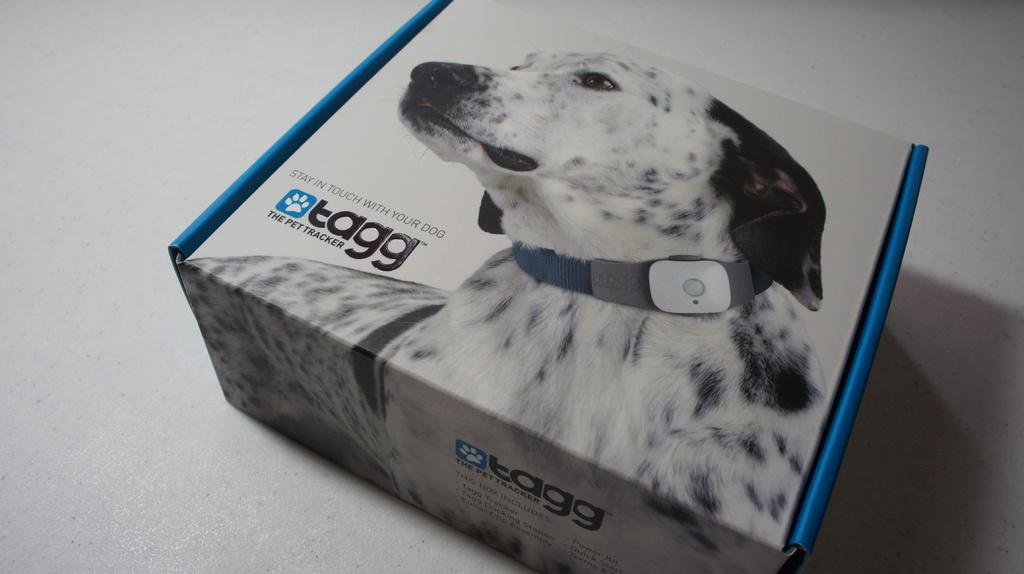Provide a one-sentence caption for the provided image. An electronic dog leash made by the brand Tagg. 